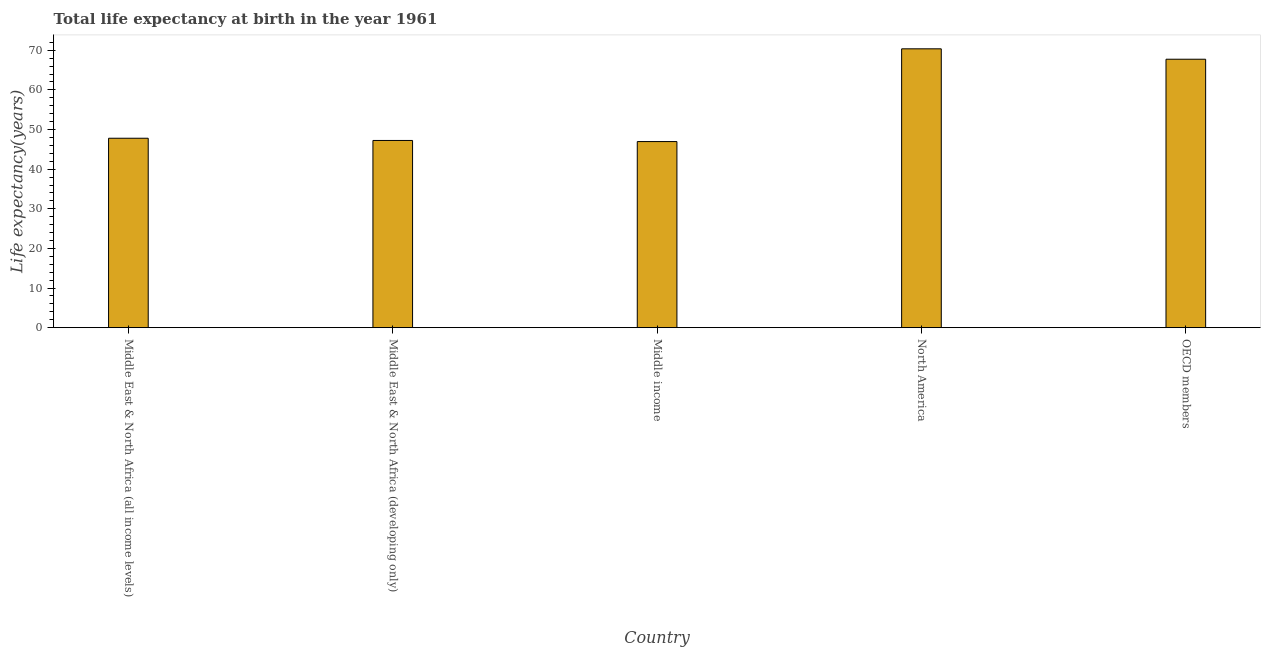Does the graph contain any zero values?
Your answer should be compact. No. What is the title of the graph?
Your answer should be compact. Total life expectancy at birth in the year 1961. What is the label or title of the Y-axis?
Provide a succinct answer. Life expectancy(years). What is the life expectancy at birth in Middle East & North Africa (all income levels)?
Your response must be concise. 47.8. Across all countries, what is the maximum life expectancy at birth?
Provide a succinct answer. 70.37. Across all countries, what is the minimum life expectancy at birth?
Your answer should be compact. 46.96. In which country was the life expectancy at birth maximum?
Give a very brief answer. North America. What is the sum of the life expectancy at birth?
Your answer should be very brief. 280.11. What is the difference between the life expectancy at birth in Middle East & North Africa (all income levels) and Middle income?
Keep it short and to the point. 0.84. What is the average life expectancy at birth per country?
Your response must be concise. 56.02. What is the median life expectancy at birth?
Ensure brevity in your answer.  47.8. In how many countries, is the life expectancy at birth greater than 64 years?
Your answer should be very brief. 2. What is the ratio of the life expectancy at birth in Middle East & North Africa (all income levels) to that in Middle income?
Your answer should be very brief. 1.02. Is the difference between the life expectancy at birth in Middle income and North America greater than the difference between any two countries?
Provide a short and direct response. Yes. What is the difference between the highest and the second highest life expectancy at birth?
Keep it short and to the point. 2.63. What is the difference between the highest and the lowest life expectancy at birth?
Provide a succinct answer. 23.41. In how many countries, is the life expectancy at birth greater than the average life expectancy at birth taken over all countries?
Provide a short and direct response. 2. How many bars are there?
Your answer should be very brief. 5. Are all the bars in the graph horizontal?
Offer a very short reply. No. What is the difference between two consecutive major ticks on the Y-axis?
Your answer should be very brief. 10. Are the values on the major ticks of Y-axis written in scientific E-notation?
Give a very brief answer. No. What is the Life expectancy(years) of Middle East & North Africa (all income levels)?
Provide a succinct answer. 47.8. What is the Life expectancy(years) in Middle East & North Africa (developing only)?
Provide a succinct answer. 47.24. What is the Life expectancy(years) in Middle income?
Provide a succinct answer. 46.96. What is the Life expectancy(years) of North America?
Offer a very short reply. 70.37. What is the Life expectancy(years) of OECD members?
Your response must be concise. 67.74. What is the difference between the Life expectancy(years) in Middle East & North Africa (all income levels) and Middle East & North Africa (developing only)?
Your answer should be very brief. 0.56. What is the difference between the Life expectancy(years) in Middle East & North Africa (all income levels) and Middle income?
Provide a succinct answer. 0.84. What is the difference between the Life expectancy(years) in Middle East & North Africa (all income levels) and North America?
Provide a succinct answer. -22.57. What is the difference between the Life expectancy(years) in Middle East & North Africa (all income levels) and OECD members?
Your answer should be very brief. -19.94. What is the difference between the Life expectancy(years) in Middle East & North Africa (developing only) and Middle income?
Give a very brief answer. 0.28. What is the difference between the Life expectancy(years) in Middle East & North Africa (developing only) and North America?
Offer a very short reply. -23.13. What is the difference between the Life expectancy(years) in Middle East & North Africa (developing only) and OECD members?
Provide a short and direct response. -20.5. What is the difference between the Life expectancy(years) in Middle income and North America?
Your answer should be compact. -23.41. What is the difference between the Life expectancy(years) in Middle income and OECD members?
Provide a short and direct response. -20.78. What is the difference between the Life expectancy(years) in North America and OECD members?
Give a very brief answer. 2.63. What is the ratio of the Life expectancy(years) in Middle East & North Africa (all income levels) to that in North America?
Provide a succinct answer. 0.68. What is the ratio of the Life expectancy(years) in Middle East & North Africa (all income levels) to that in OECD members?
Your response must be concise. 0.71. What is the ratio of the Life expectancy(years) in Middle East & North Africa (developing only) to that in Middle income?
Your answer should be very brief. 1.01. What is the ratio of the Life expectancy(years) in Middle East & North Africa (developing only) to that in North America?
Ensure brevity in your answer.  0.67. What is the ratio of the Life expectancy(years) in Middle East & North Africa (developing only) to that in OECD members?
Provide a succinct answer. 0.7. What is the ratio of the Life expectancy(years) in Middle income to that in North America?
Your answer should be compact. 0.67. What is the ratio of the Life expectancy(years) in Middle income to that in OECD members?
Ensure brevity in your answer.  0.69. What is the ratio of the Life expectancy(years) in North America to that in OECD members?
Ensure brevity in your answer.  1.04. 